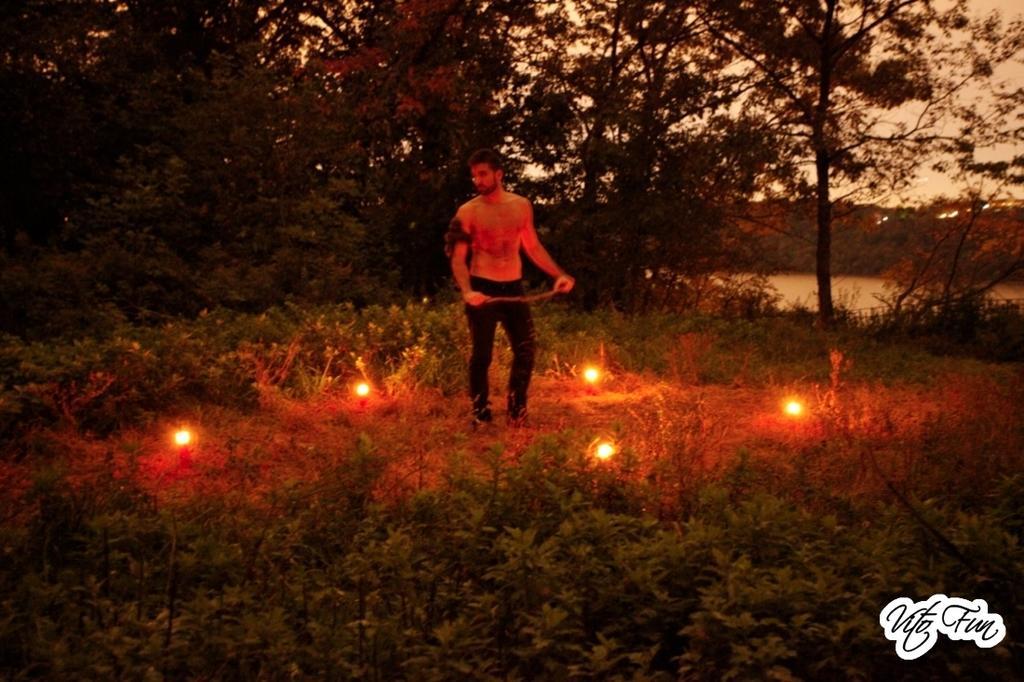How would you summarize this image in a sentence or two? In this image in the center there is one person who is standing, and he is holding a stick. At the bottom there is grass and some lights, and in the background there is a sea and trees. And at the top there is sky. 